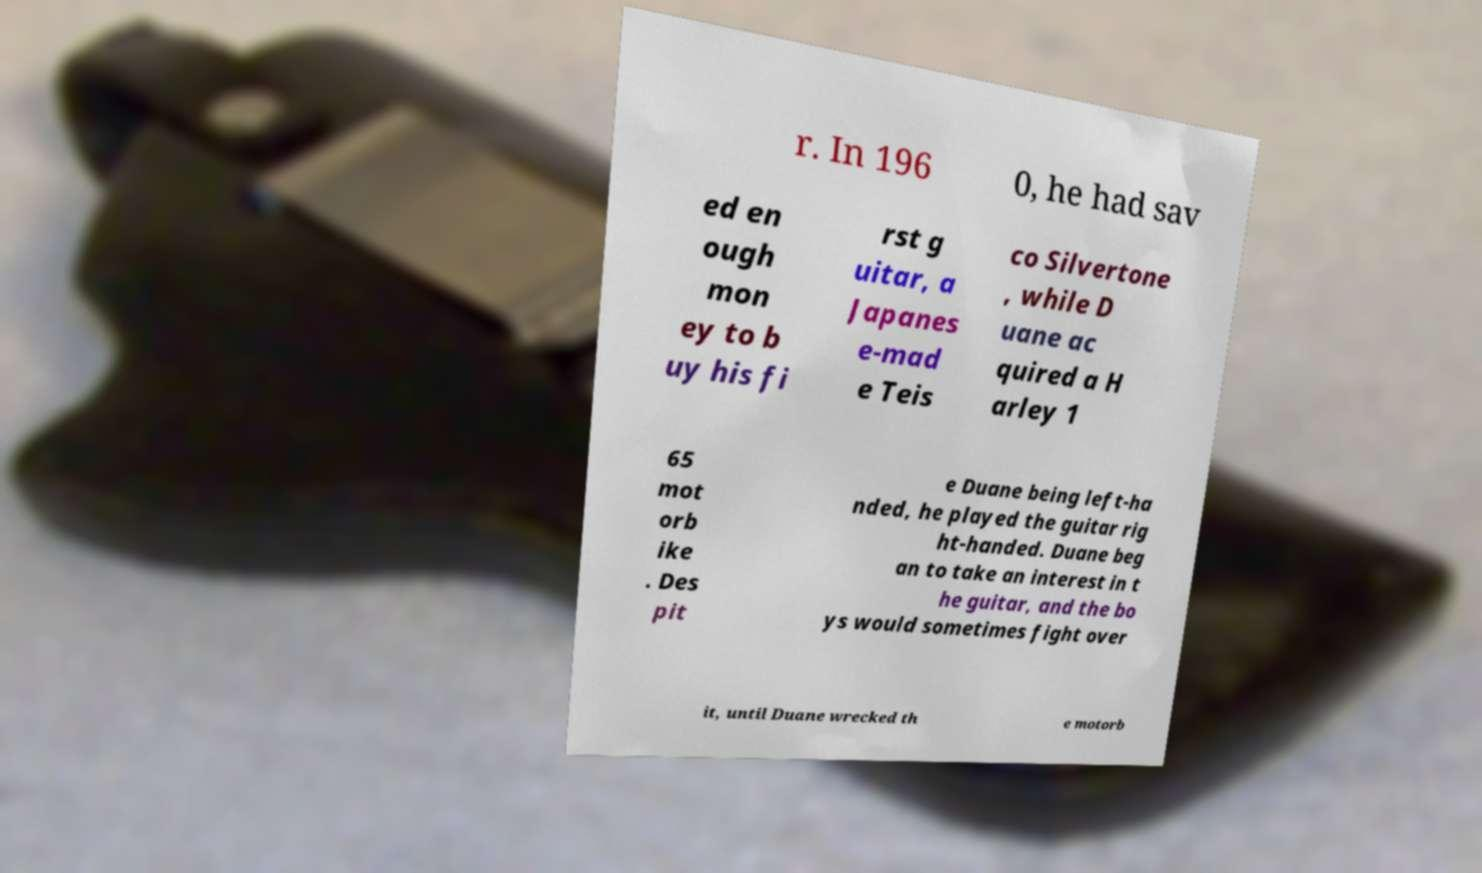Please read and relay the text visible in this image. What does it say? r. In 196 0, he had sav ed en ough mon ey to b uy his fi rst g uitar, a Japanes e-mad e Teis co Silvertone , while D uane ac quired a H arley 1 65 mot orb ike . Des pit e Duane being left-ha nded, he played the guitar rig ht-handed. Duane beg an to take an interest in t he guitar, and the bo ys would sometimes fight over it, until Duane wrecked th e motorb 